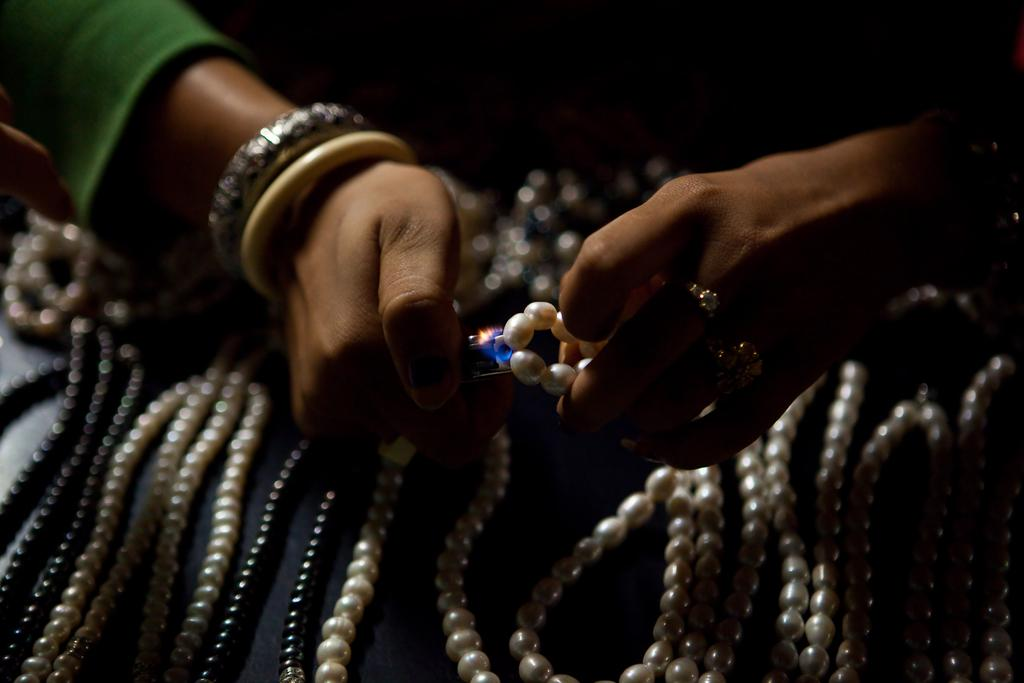What is the person holding in their hands in the image? The person's hands are holding a pearl chain and another object. What can be seen on the platform in the image? There are pearl chains on a platform. What type of pot is being used to talk to the pearl chains in the image? There is no pot or talking involved in the image; it features a person holding a pearl chain and another object, as well as pearl chains on a platform. 